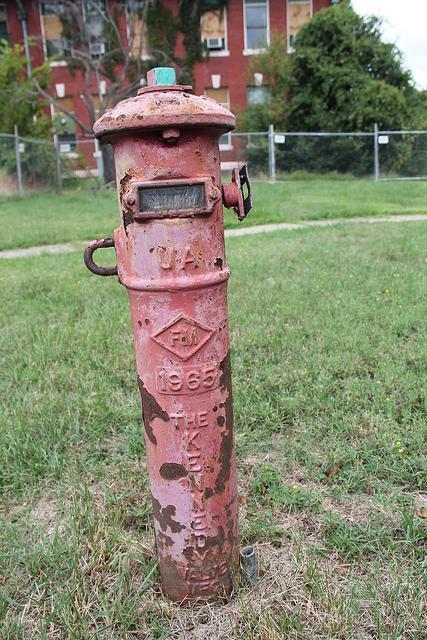How many train tracks do you see?
Give a very brief answer. 0. 